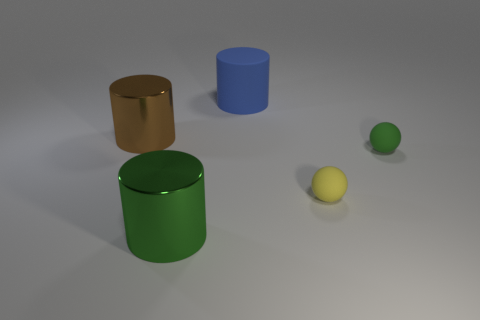Subtract all brown shiny cylinders. How many cylinders are left? 2 Add 1 brown cylinders. How many objects exist? 6 Subtract all cylinders. How many objects are left? 2 Subtract all cyan cylinders. Subtract all yellow cubes. How many cylinders are left? 3 Subtract all small cyan cubes. Subtract all green metallic objects. How many objects are left? 4 Add 5 matte things. How many matte things are left? 8 Add 2 green matte objects. How many green matte objects exist? 3 Subtract 1 green cylinders. How many objects are left? 4 